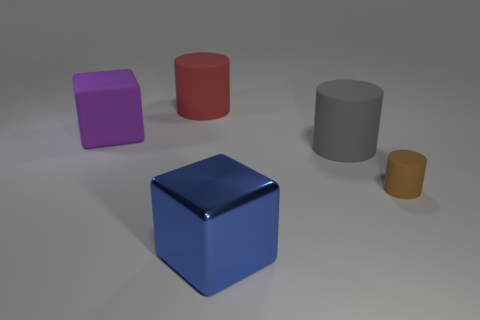Subtract all red matte cylinders. How many cylinders are left? 2 Add 3 large purple metallic cylinders. How many objects exist? 8 Subtract all brown cylinders. How many cylinders are left? 2 Subtract 3 cylinders. How many cylinders are left? 0 Subtract all cylinders. How many objects are left? 2 Subtract 0 brown blocks. How many objects are left? 5 Subtract all purple cubes. Subtract all green cylinders. How many cubes are left? 1 Subtract all tiny brown metallic cylinders. Subtract all blue blocks. How many objects are left? 4 Add 2 red rubber cylinders. How many red rubber cylinders are left? 3 Add 1 small rubber things. How many small rubber things exist? 2 